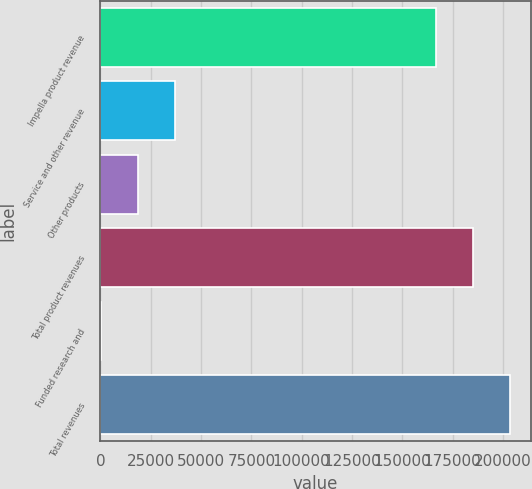Convert chart. <chart><loc_0><loc_0><loc_500><loc_500><bar_chart><fcel>Impella product revenue<fcel>Service and other revenue<fcel>Other products<fcel>Total product revenues<fcel>Funded research and<fcel>Total revenues<nl><fcel>166971<fcel>37019<fcel>18691<fcel>185299<fcel>363<fcel>203627<nl></chart> 